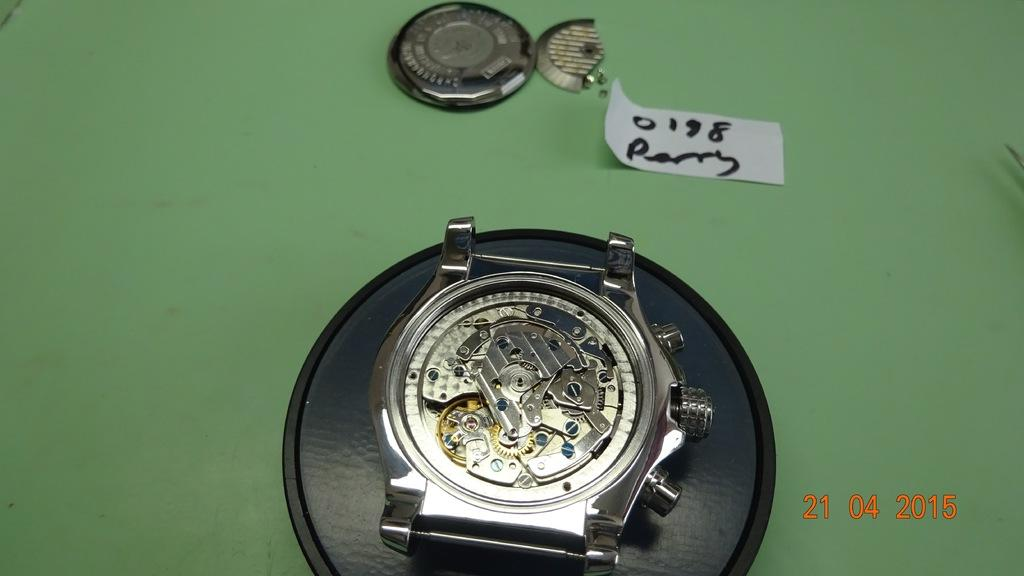<image>
Relay a brief, clear account of the picture shown. A display of the interior of a watch with a date of 21-04-2015. 